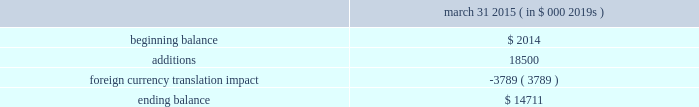Abiomed , inc .
And subsidiaries notes to consolidated financial statements 2014 ( continued ) note 8 .
Goodwill and in-process research and development ( continued ) the company has no accumulated impairment losses on goodwill .
The company performed a step 0 qualitative assessment during the annual impairment review for fiscal 2015 as of october 31 , 2014 and concluded that it is not more likely than not that the fair value of the company 2019s single reporting unit is less than its carrying amount .
Therefore , the two-step goodwill impairment test for the reporting unit was not necessary in fiscal 2015 .
As described in note 3 .
201cacquisitions , 201d in july 2014 , the company acquired ecp and ais and recorded $ 18.5 million of ipr&d .
The estimated fair value of the ipr&d was determined using a probability-weighted income approach , which discounts expected future cash flows to present value .
The projected cash flows from the expandable catheter pump technology were based on certain key assumptions , including estimates of future revenue and expenses , taking into account the stage of development of the technology at the acquisition date and the time and resources needed to complete development .
The company used a discount rate of 22.5% ( 22.5 % ) and cash flows that have been probability adjusted to reflect the risks of product commercialization , which the company believes are appropriate and representative of market participant assumptions .
The carrying value of the company 2019s ipr&d assets and the change in the balance for the year ended march 31 , 2015 is as follows : march 31 , ( in $ 000 2019s ) .
Note 9 .
Stockholders 2019 equity class b preferred stock the company has authorized 1000000 shares of class b preferred stock , $ .01 par value , of which the board of directors can set the designation , rights and privileges .
No shares of class b preferred stock have been issued or are outstanding .
Stock repurchase program in november 2012 , the company 2019s board of directors authorized a stock repurchase program for up to $ 15.0 million of its common stock .
The company financed the stock repurchase program with its available cash .
During the year ended march 31 , 2013 , the company repurchased 1123587 shares for $ 15.0 million in open market purchases at an average cost of $ 13.39 per share , including commission expense .
The company completed the purchase of common stock under this stock repurchase program in january 2013 .
Note 10 .
Stock award plans and stock-based compensation stock award plans the company grants stock options and restricted stock awards to employees and others .
All outstanding stock options of the company as of march 31 , 2015 were granted with an exercise price equal to the fair market value on the date of grant .
Outstanding stock options , if not exercised , expire 10 years from the date of grant .
The company 2019s 2008 stock incentive plan ( the 201cplan 201d ) authorizes the grant of a variety of equity awards to the company 2019s officers , directors , employees , consultants and advisers , including awards of unrestricted and restricted stock , restricted stock units , incentive and nonqualified stock options to purchase shares of common stock , performance share awards and stock appreciation rights .
The plan provides that options may only be granted at the current market value on the date of grant .
Each share of stock issued pursuant to a stock option or stock appreciation right counts as one share against the maximum number of shares issuable under the plan , while each share of stock issued .
Assuming the same impact of foreign currency translation as in the fiscal year 2015 , what would be the ending balance of in process \\nr&d assets in fiscal 2016? 
Computations: ((14711 - 3789) * 1000)
Answer: 10922000.0. 